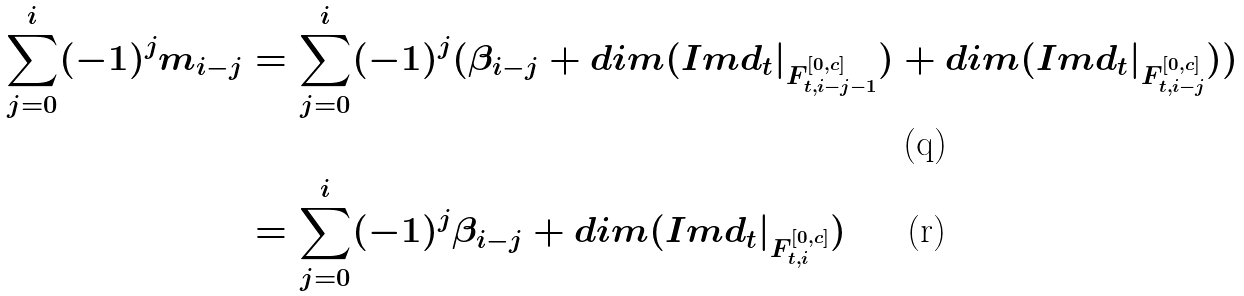<formula> <loc_0><loc_0><loc_500><loc_500>\sum _ { j = 0 } ^ { i } ( - 1 ) ^ { j } m _ { i - j } & = \sum _ { j = 0 } ^ { i } ( - 1 ) ^ { j } ( \beta _ { i - j } + d i m ( I m d _ { t } | _ { F ^ { [ 0 , c ] } _ { t , i - j - 1 } } ) + d i m ( I m d _ { t } | _ { F ^ { [ 0 , c ] } _ { t , i - j } } ) ) \\ & = \sum _ { j = 0 } ^ { i } ( - 1 ) ^ { j } \beta _ { i - j } + d i m ( I m d _ { t } | _ { F _ { t , i } ^ { [ 0 , c ] } } )</formula> 